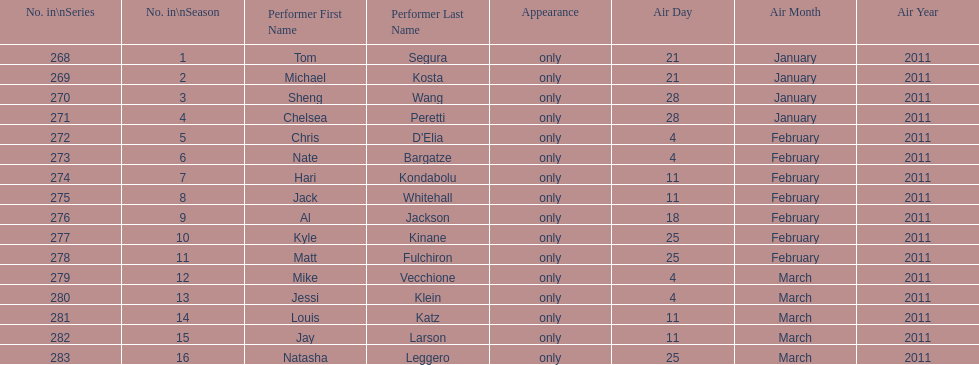How many episodes only had one performer? 16. 